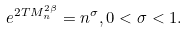<formula> <loc_0><loc_0><loc_500><loc_500>e ^ { 2 T M _ { n } ^ { 2 \beta } } = n ^ { \sigma } , 0 < \sigma < 1 .</formula> 